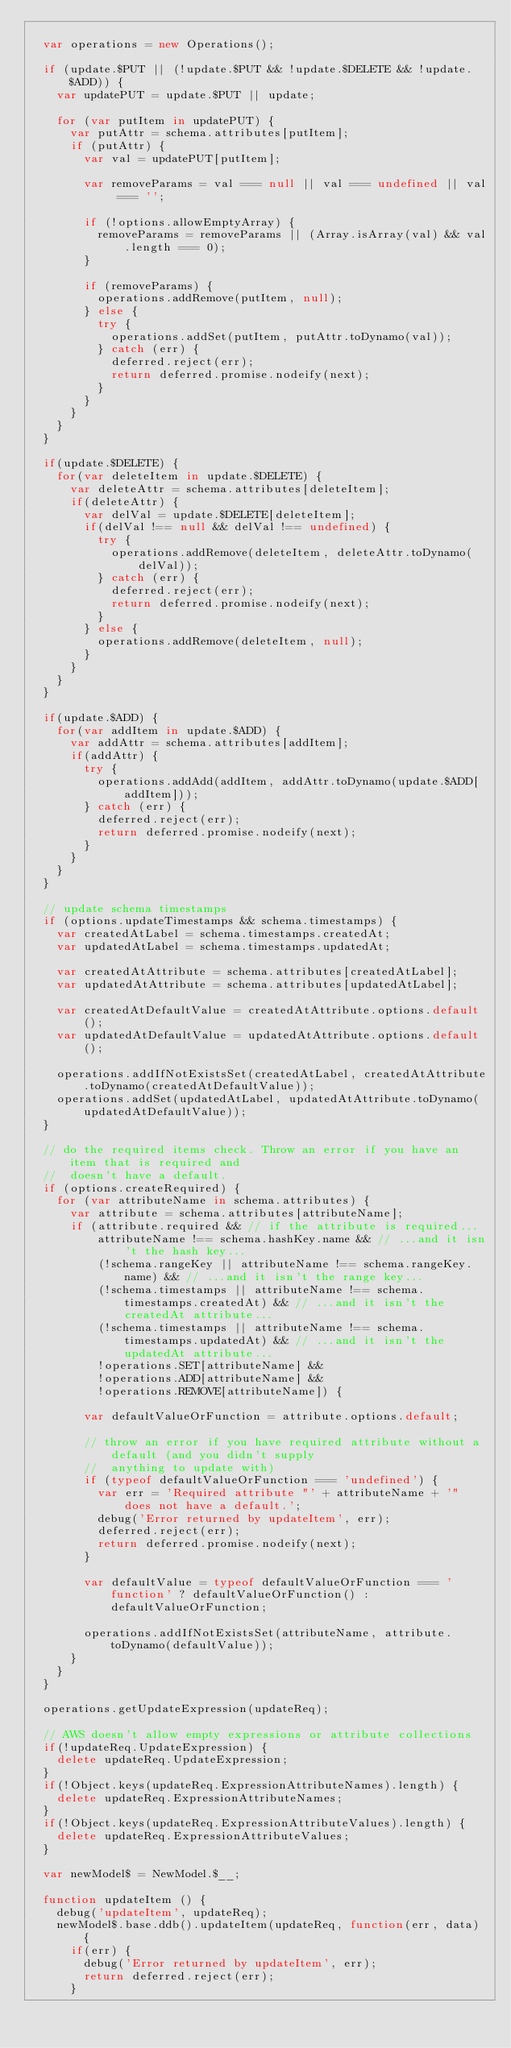Convert code to text. <code><loc_0><loc_0><loc_500><loc_500><_JavaScript_>
  var operations = new Operations();

  if (update.$PUT || (!update.$PUT && !update.$DELETE && !update.$ADD)) {
    var updatePUT = update.$PUT || update;

    for (var putItem in updatePUT) {
      var putAttr = schema.attributes[putItem];
      if (putAttr) {
        var val = updatePUT[putItem];

        var removeParams = val === null || val === undefined || val === '';

        if (!options.allowEmptyArray) {
          removeParams = removeParams || (Array.isArray(val) && val.length === 0);
        }

        if (removeParams) {
          operations.addRemove(putItem, null);
        } else {
          try {
            operations.addSet(putItem, putAttr.toDynamo(val));
          } catch (err) {
            deferred.reject(err);
            return deferred.promise.nodeify(next);
          }
        }
      }
    }
  }

  if(update.$DELETE) {
    for(var deleteItem in update.$DELETE) {
      var deleteAttr = schema.attributes[deleteItem];
      if(deleteAttr) {
        var delVal = update.$DELETE[deleteItem];
        if(delVal !== null && delVal !== undefined) {
          try {
            operations.addRemove(deleteItem, deleteAttr.toDynamo(delVal));
          } catch (err) {
            deferred.reject(err);
            return deferred.promise.nodeify(next);
          }
        } else {
          operations.addRemove(deleteItem, null);
        }
      }
    }
  }

  if(update.$ADD) {
    for(var addItem in update.$ADD) {
      var addAttr = schema.attributes[addItem];
      if(addAttr) {
        try {
          operations.addAdd(addItem, addAttr.toDynamo(update.$ADD[addItem]));
        } catch (err) {
          deferred.reject(err);
          return deferred.promise.nodeify(next);
        }
      }
    }
  }

  // update schema timestamps
  if (options.updateTimestamps && schema.timestamps) {
    var createdAtLabel = schema.timestamps.createdAt;
    var updatedAtLabel = schema.timestamps.updatedAt;

    var createdAtAttribute = schema.attributes[createdAtLabel];
    var updatedAtAttribute = schema.attributes[updatedAtLabel];

    var createdAtDefaultValue = createdAtAttribute.options.default();
    var updatedAtDefaultValue = updatedAtAttribute.options.default();

    operations.addIfNotExistsSet(createdAtLabel, createdAtAttribute.toDynamo(createdAtDefaultValue));
    operations.addSet(updatedAtLabel, updatedAtAttribute.toDynamo(updatedAtDefaultValue));
  }

  // do the required items check. Throw an error if you have an item that is required and
  //  doesn't have a default.
  if (options.createRequired) {
    for (var attributeName in schema.attributes) {
      var attribute = schema.attributes[attributeName];
      if (attribute.required && // if the attribute is required...
          attributeName !== schema.hashKey.name && // ...and it isn't the hash key...
          (!schema.rangeKey || attributeName !== schema.rangeKey.name) && // ...and it isn't the range key...
          (!schema.timestamps || attributeName !== schema.timestamps.createdAt) && // ...and it isn't the createdAt attribute...
          (!schema.timestamps || attributeName !== schema.timestamps.updatedAt) && // ...and it isn't the updatedAt attribute...
          !operations.SET[attributeName] &&
          !operations.ADD[attributeName] &&
          !operations.REMOVE[attributeName]) {

        var defaultValueOrFunction = attribute.options.default;

        // throw an error if you have required attribute without a default (and you didn't supply
        //  anything to update with)
        if (typeof defaultValueOrFunction === 'undefined') {
          var err = 'Required attribute "' + attributeName + '" does not have a default.';
          debug('Error returned by updateItem', err);
          deferred.reject(err);
          return deferred.promise.nodeify(next);
        }

        var defaultValue = typeof defaultValueOrFunction === 'function' ? defaultValueOrFunction() : defaultValueOrFunction;

        operations.addIfNotExistsSet(attributeName, attribute.toDynamo(defaultValue));
      }
    }
  }

  operations.getUpdateExpression(updateReq);

  // AWS doesn't allow empty expressions or attribute collections
  if(!updateReq.UpdateExpression) {
    delete updateReq.UpdateExpression;
  }
  if(!Object.keys(updateReq.ExpressionAttributeNames).length) {
    delete updateReq.ExpressionAttributeNames;
  }
  if(!Object.keys(updateReq.ExpressionAttributeValues).length) {
    delete updateReq.ExpressionAttributeValues;
  }

  var newModel$ = NewModel.$__;

  function updateItem () {
    debug('updateItem', updateReq);
    newModel$.base.ddb().updateItem(updateReq, function(err, data) {
      if(err) {
        debug('Error returned by updateItem', err);
        return deferred.reject(err);
      }</code> 